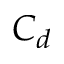<formula> <loc_0><loc_0><loc_500><loc_500>C _ { d }</formula> 